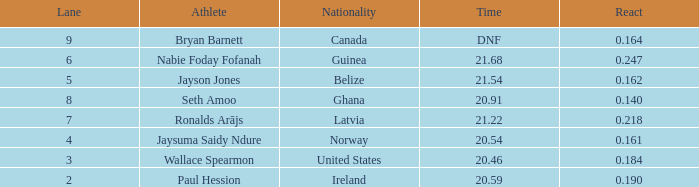What is the lowest lane when react is more than 0.164 and the nationality is guinea? 6.0. 